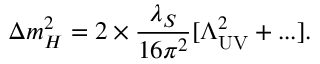<formula> <loc_0><loc_0><loc_500><loc_500>\Delta m _ { H } ^ { 2 } = 2 \times { \frac { \lambda _ { S } } { 1 6 \pi ^ { 2 } } } [ \Lambda _ { U V } ^ { 2 } + \dots ] .</formula> 